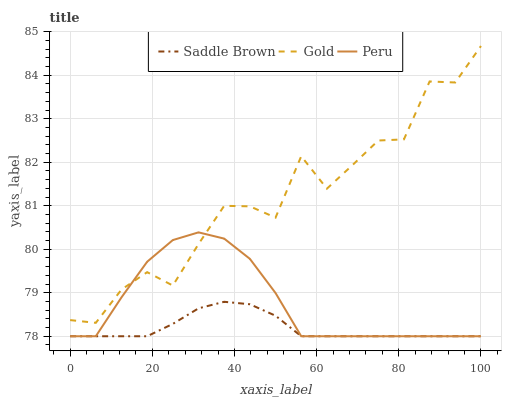Does Saddle Brown have the minimum area under the curve?
Answer yes or no. Yes. Does Gold have the maximum area under the curve?
Answer yes or no. Yes. Does Gold have the minimum area under the curve?
Answer yes or no. No. Does Saddle Brown have the maximum area under the curve?
Answer yes or no. No. Is Saddle Brown the smoothest?
Answer yes or no. Yes. Is Gold the roughest?
Answer yes or no. Yes. Is Gold the smoothest?
Answer yes or no. No. Is Saddle Brown the roughest?
Answer yes or no. No. Does Peru have the lowest value?
Answer yes or no. Yes. Does Gold have the lowest value?
Answer yes or no. No. Does Gold have the highest value?
Answer yes or no. Yes. Does Saddle Brown have the highest value?
Answer yes or no. No. Is Saddle Brown less than Gold?
Answer yes or no. Yes. Is Gold greater than Saddle Brown?
Answer yes or no. Yes. Does Saddle Brown intersect Peru?
Answer yes or no. Yes. Is Saddle Brown less than Peru?
Answer yes or no. No. Is Saddle Brown greater than Peru?
Answer yes or no. No. Does Saddle Brown intersect Gold?
Answer yes or no. No. 